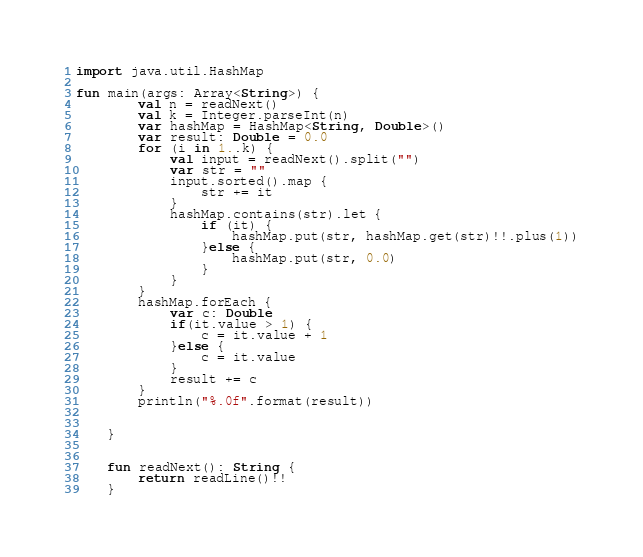Convert code to text. <code><loc_0><loc_0><loc_500><loc_500><_Kotlin_>import java.util.HashMap

fun main(args: Array<String>) {
        val n = readNext()
        val k = Integer.parseInt(n)
        var hashMap = HashMap<String, Double>()
        var result: Double = 0.0
        for (i in 1..k) {
            val input = readNext().split("")
            var str = ""
            input.sorted().map {
                str += it
            }
            hashMap.contains(str).let {
                if (it) {
                    hashMap.put(str, hashMap.get(str)!!.plus(1))
                }else {
                    hashMap.put(str, 0.0)
                }
            }
        }
        hashMap.forEach {
            var c: Double
            if(it.value > 1) {
                c = it.value + 1
            }else {
                c = it.value
            }
            result += c
        }
        println("%.0f".format(result))


    }


    fun readNext(): String {
        return readLine()!!
    }
</code> 